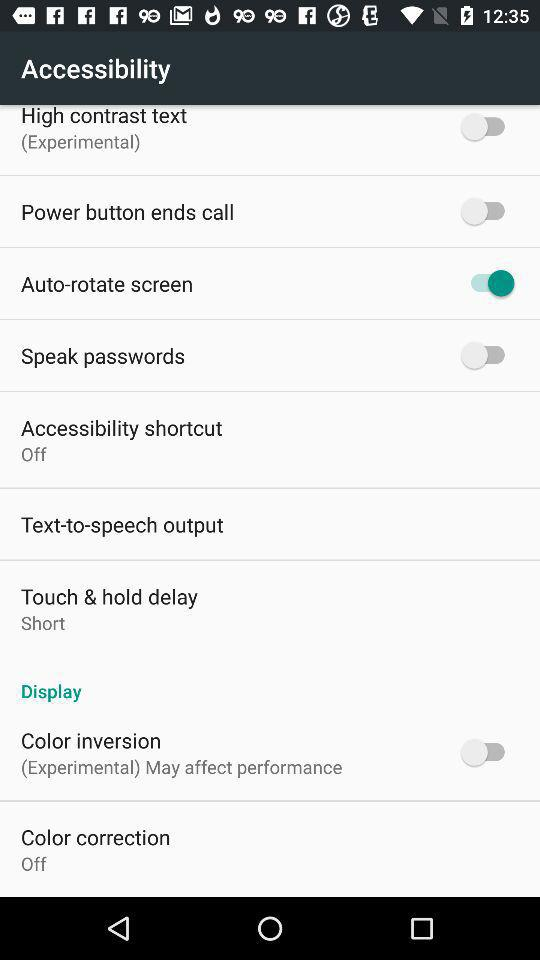Which colors are being corrected?
When the provided information is insufficient, respond with <no answer>. <no answer> 